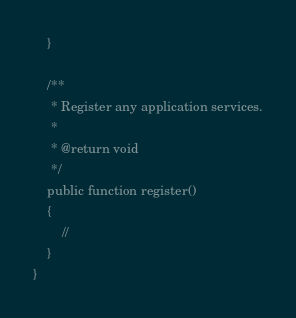<code> <loc_0><loc_0><loc_500><loc_500><_PHP_>    }

    /**
     * Register any application services.
     *
     * @return void
     */
    public function register()
    {
        //
    }
}
</code> 